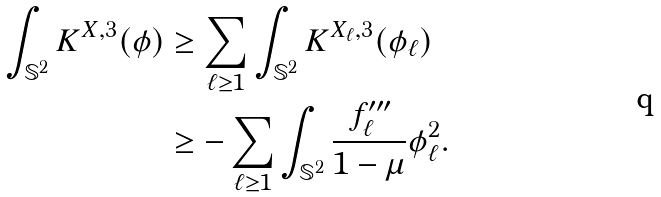Convert formula to latex. <formula><loc_0><loc_0><loc_500><loc_500>\int _ { \mathbb { S } ^ { 2 } } K ^ { X , 3 } ( \phi ) & \geq \sum _ { \ell \geq 1 } \int _ { \mathbb { S } ^ { 2 } } K ^ { X _ { \ell } , 3 } ( \phi _ { \ell } ) \\ & \geq - \sum _ { \ell \geq 1 } \int _ { \mathbb { S } ^ { 2 } } \frac { f _ { \ell } ^ { \prime \prime \prime } } { 1 - \mu } \phi _ { \ell } ^ { 2 } .</formula> 